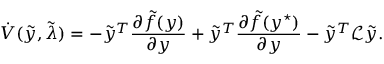Convert formula to latex. <formula><loc_0><loc_0><loc_500><loc_500>\dot { V } ( \tilde { y } , \tilde { \lambda } ) = - \tilde { y } ^ { T } \frac { \partial \tilde { f } ( y ) } { \partial y } + \tilde { y } ^ { T } \frac { \partial \tilde { f } ( y ^ { ^ { * } } ) } { \partial y } - \tilde { y } ^ { T } \mathcal { L } \tilde { y } .</formula> 